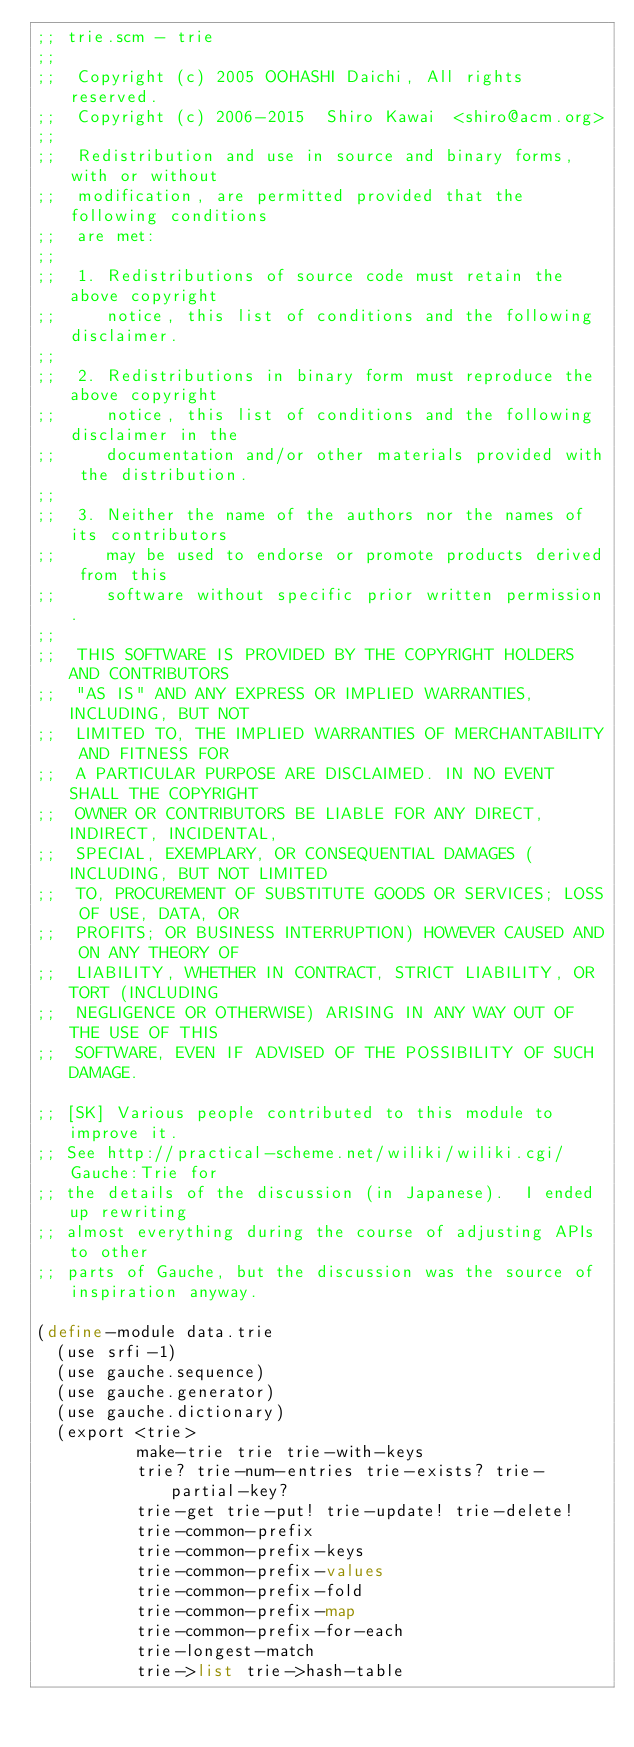<code> <loc_0><loc_0><loc_500><loc_500><_Scheme_>;; trie.scm - trie
;;
;;  Copyright (c) 2005 OOHASHI Daichi, All rights reserved.
;;  Copyright (c) 2006-2015  Shiro Kawai  <shiro@acm.org>
;;
;;  Redistribution and use in source and binary forms, with or without
;;  modification, are permitted provided that the following conditions
;;  are met:
;;
;;  1. Redistributions of source code must retain the above copyright
;;     notice, this list of conditions and the following disclaimer.
;;
;;  2. Redistributions in binary form must reproduce the above copyright
;;     notice, this list of conditions and the following disclaimer in the
;;     documentation and/or other materials provided with the distribution.
;;
;;  3. Neither the name of the authors nor the names of its contributors
;;     may be used to endorse or promote products derived from this
;;     software without specific prior written permission.
;;
;;  THIS SOFTWARE IS PROVIDED BY THE COPYRIGHT HOLDERS AND CONTRIBUTORS
;;  "AS IS" AND ANY EXPRESS OR IMPLIED WARRANTIES, INCLUDING, BUT NOT
;;  LIMITED TO, THE IMPLIED WARRANTIES OF MERCHANTABILITY AND FITNESS FOR
;;  A PARTICULAR PURPOSE ARE DISCLAIMED. IN NO EVENT SHALL THE COPYRIGHT
;;  OWNER OR CONTRIBUTORS BE LIABLE FOR ANY DIRECT, INDIRECT, INCIDENTAL,
;;  SPECIAL, EXEMPLARY, OR CONSEQUENTIAL DAMAGES (INCLUDING, BUT NOT LIMITED
;;  TO, PROCUREMENT OF SUBSTITUTE GOODS OR SERVICES; LOSS OF USE, DATA, OR
;;  PROFITS; OR BUSINESS INTERRUPTION) HOWEVER CAUSED AND ON ANY THEORY OF
;;  LIABILITY, WHETHER IN CONTRACT, STRICT LIABILITY, OR TORT (INCLUDING
;;  NEGLIGENCE OR OTHERWISE) ARISING IN ANY WAY OUT OF THE USE OF THIS
;;  SOFTWARE, EVEN IF ADVISED OF THE POSSIBILITY OF SUCH DAMAGE.

;; [SK] Various people contributed to this module to improve it.
;; See http://practical-scheme.net/wiliki/wiliki.cgi/Gauche:Trie for
;; the details of the discussion (in Japanese).  I ended up rewriting
;; almost everything during the course of adjusting APIs to other
;; parts of Gauche, but the discussion was the source of inspiration anyway.

(define-module data.trie
  (use srfi-1)
  (use gauche.sequence)
  (use gauche.generator)
  (use gauche.dictionary)
  (export <trie>
          make-trie trie trie-with-keys
          trie? trie-num-entries trie-exists? trie-partial-key?
          trie-get trie-put! trie-update! trie-delete!
          trie-common-prefix
          trie-common-prefix-keys
          trie-common-prefix-values
          trie-common-prefix-fold
          trie-common-prefix-map
          trie-common-prefix-for-each
          trie-longest-match
          trie->list trie->hash-table</code> 